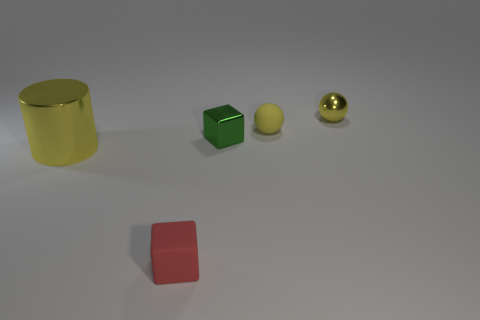Add 2 big blue things. How many objects exist? 7 Subtract all spheres. How many objects are left? 3 Add 4 yellow metallic cylinders. How many yellow metallic cylinders are left? 5 Add 2 large cyan cylinders. How many large cyan cylinders exist? 2 Subtract 1 yellow spheres. How many objects are left? 4 Subtract all large metal cylinders. Subtract all yellow shiny cylinders. How many objects are left? 3 